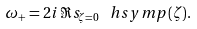Convert formula to latex. <formula><loc_0><loc_0><loc_500><loc_500>\omega _ { + } = 2 i \, \Re s _ { \zeta = 0 } \, \ h s y m p ( \zeta ) .</formula> 